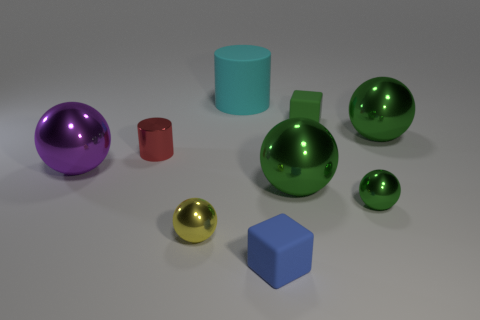Subtract all green cubes. How many green balls are left? 3 Subtract all red balls. Subtract all red cylinders. How many balls are left? 5 Add 1 large blocks. How many objects exist? 10 Subtract all cylinders. How many objects are left? 7 Add 5 green objects. How many green objects are left? 9 Add 2 matte objects. How many matte objects exist? 5 Subtract 1 blue blocks. How many objects are left? 8 Subtract all large cyan matte objects. Subtract all rubber cylinders. How many objects are left? 7 